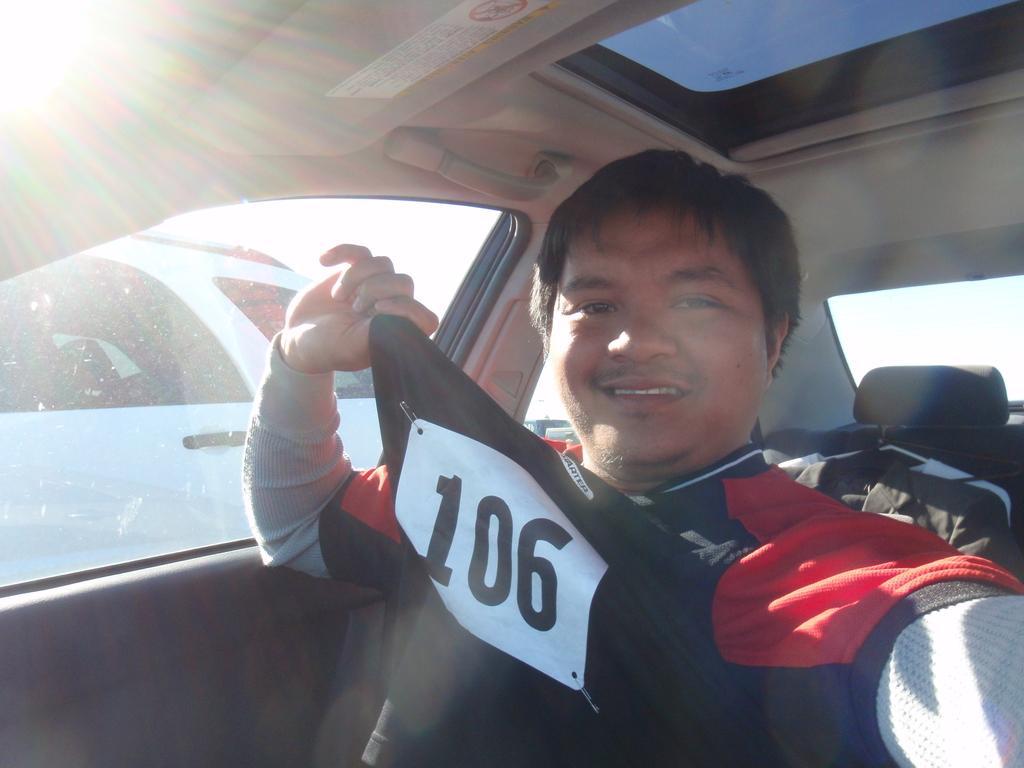How would you summarize this image in a sentence or two? In this image I can see a man wearing a t-shirt sitting in a car and smiling. 